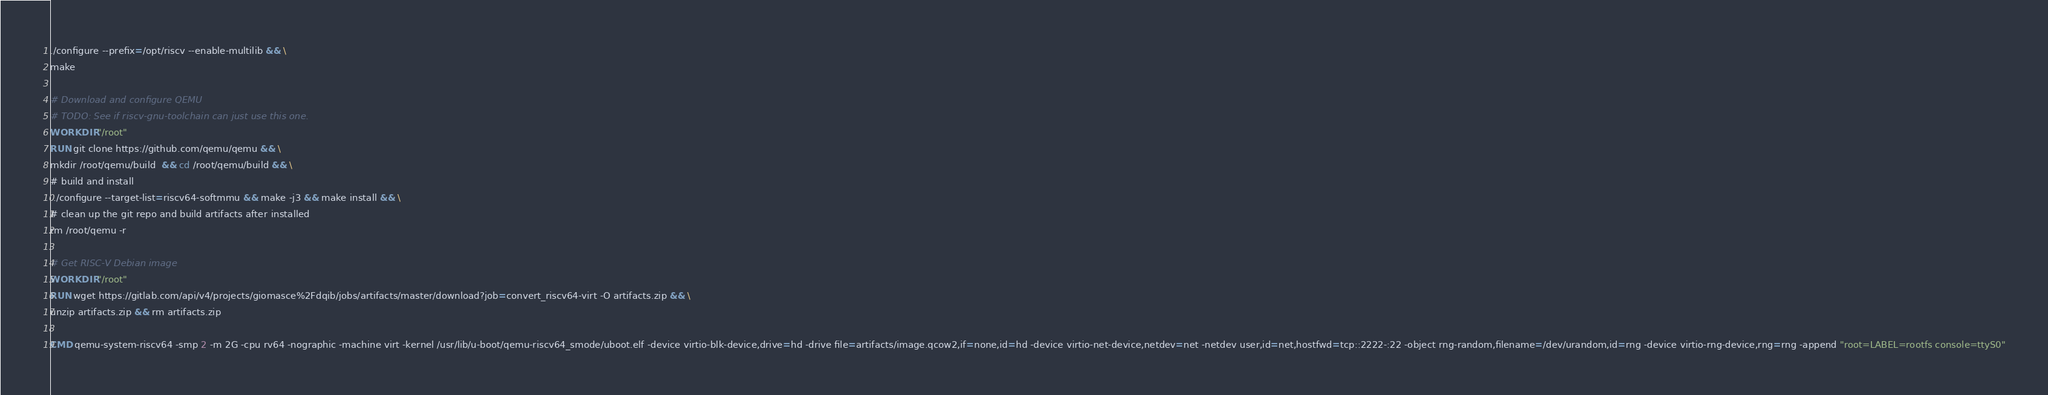Convert code to text. <code><loc_0><loc_0><loc_500><loc_500><_Dockerfile_>./configure --prefix=/opt/riscv --enable-multilib && \
make

# Download and configure QEMU
# TODO: See if riscv-gnu-toolchain can just use this one.
WORKDIR "/root"
RUN git clone https://github.com/qemu/qemu && \ 
mkdir /root/qemu/build  && cd /root/qemu/build && \
# build and install
../configure --target-list=riscv64-softmmu && make -j3 && make install && \
# clean up the git repo and build artifacts after installed
rm /root/qemu -r

# Get RISC-V Debian image
WORKDIR "/root"
RUN wget https://gitlab.com/api/v4/projects/giomasce%2Fdqib/jobs/artifacts/master/download?job=convert_riscv64-virt -O artifacts.zip && \
unzip artifacts.zip && rm artifacts.zip

CMD qemu-system-riscv64 -smp 2 -m 2G -cpu rv64 -nographic -machine virt -kernel /usr/lib/u-boot/qemu-riscv64_smode/uboot.elf -device virtio-blk-device,drive=hd -drive file=artifacts/image.qcow2,if=none,id=hd -device virtio-net-device,netdev=net -netdev user,id=net,hostfwd=tcp::2222-:22 -object rng-random,filename=/dev/urandom,id=rng -device virtio-rng-device,rng=rng -append "root=LABEL=rootfs console=ttyS0"
</code> 